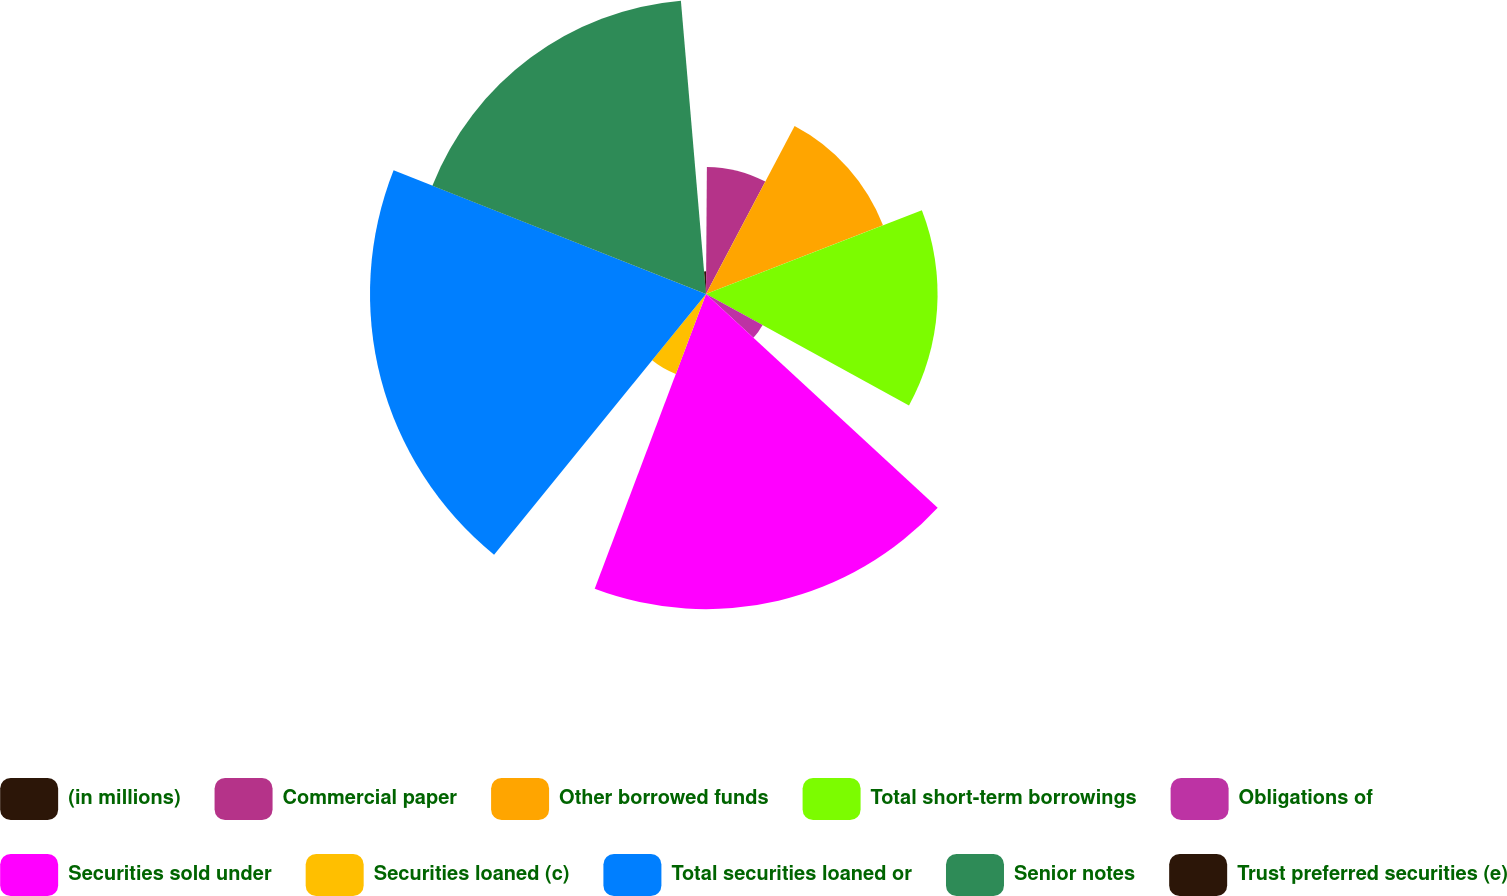<chart> <loc_0><loc_0><loc_500><loc_500><pie_chart><fcel>(in millions)<fcel>Commercial paper<fcel>Other borrowed funds<fcel>Total short-term borrowings<fcel>Obligations of<fcel>Securities sold under<fcel>Securities loaned (c)<fcel>Total securities loaned or<fcel>Senior notes<fcel>Trust preferred securities (e)<nl><fcel>0.11%<fcel>7.62%<fcel>11.38%<fcel>13.88%<fcel>3.87%<fcel>18.89%<fcel>5.12%<fcel>20.14%<fcel>17.64%<fcel>1.36%<nl></chart> 